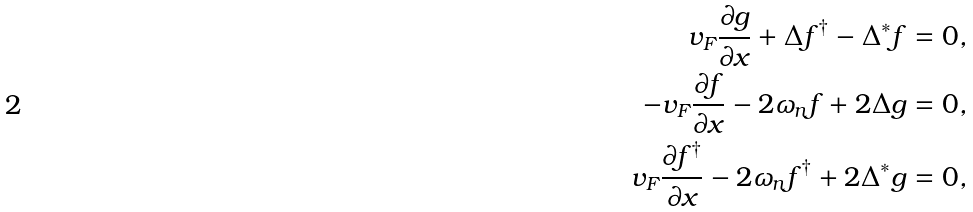<formula> <loc_0><loc_0><loc_500><loc_500>v _ { F } \frac { \partial g } { \partial x } + \Delta f ^ { \dag } - \Delta ^ { \ast } f & = 0 , \\ - v _ { F } \frac { \partial f } { \partial x } - 2 \omega _ { n } f + 2 \Delta g & = 0 , \\ v _ { F } \frac { \partial f ^ { \dag } } { \partial x } - 2 \omega _ { n } f ^ { \dag } + 2 \Delta ^ { \ast } g & = 0 ,</formula> 